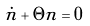Convert formula to latex. <formula><loc_0><loc_0><loc_500><loc_500>\dot { n } + \Theta n = 0</formula> 